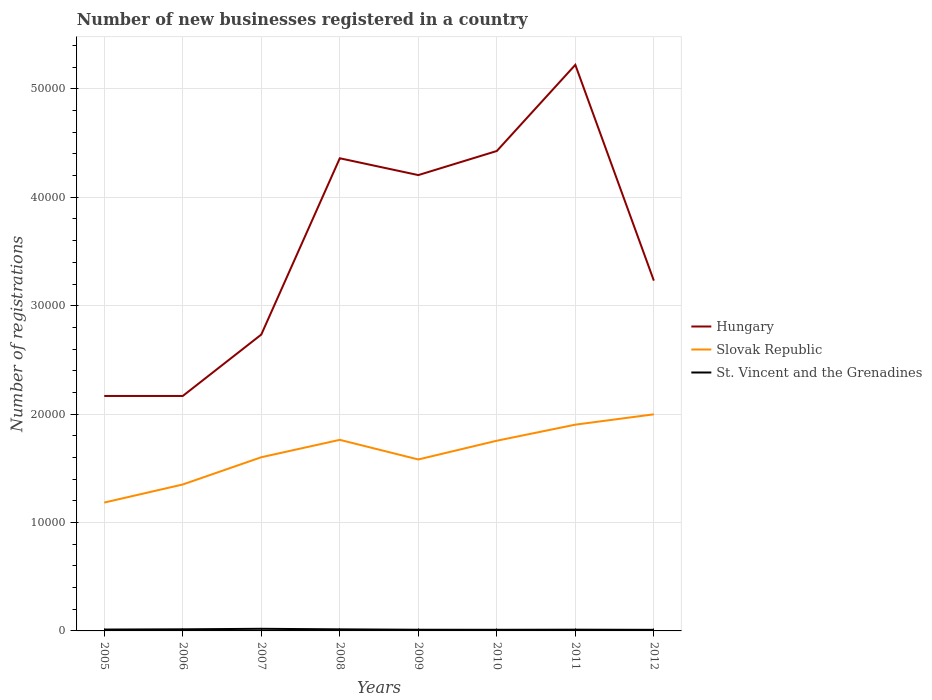How many different coloured lines are there?
Keep it short and to the point. 3. Across all years, what is the maximum number of new businesses registered in Slovak Republic?
Make the answer very short. 1.18e+04. In which year was the number of new businesses registered in Slovak Republic maximum?
Provide a short and direct response. 2005. What is the total number of new businesses registered in Slovak Republic in the graph?
Keep it short and to the point. -5519. What is the difference between the highest and the second highest number of new businesses registered in Slovak Republic?
Your response must be concise. 8139. What is the difference between the highest and the lowest number of new businesses registered in Hungary?
Your response must be concise. 4. How many years are there in the graph?
Give a very brief answer. 8. How many legend labels are there?
Make the answer very short. 3. What is the title of the graph?
Your answer should be very brief. Number of new businesses registered in a country. What is the label or title of the Y-axis?
Keep it short and to the point. Number of registrations. What is the Number of registrations in Hungary in 2005?
Your answer should be compact. 2.17e+04. What is the Number of registrations in Slovak Republic in 2005?
Offer a very short reply. 1.18e+04. What is the Number of registrations in St. Vincent and the Grenadines in 2005?
Keep it short and to the point. 127. What is the Number of registrations of Hungary in 2006?
Offer a very short reply. 2.17e+04. What is the Number of registrations of Slovak Republic in 2006?
Keep it short and to the point. 1.35e+04. What is the Number of registrations of St. Vincent and the Grenadines in 2006?
Provide a succinct answer. 149. What is the Number of registrations in Hungary in 2007?
Your answer should be compact. 2.73e+04. What is the Number of registrations of Slovak Republic in 2007?
Offer a terse response. 1.60e+04. What is the Number of registrations of St. Vincent and the Grenadines in 2007?
Your answer should be very brief. 196. What is the Number of registrations in Hungary in 2008?
Provide a succinct answer. 4.36e+04. What is the Number of registrations in Slovak Republic in 2008?
Provide a short and direct response. 1.76e+04. What is the Number of registrations in St. Vincent and the Grenadines in 2008?
Keep it short and to the point. 145. What is the Number of registrations of Hungary in 2009?
Offer a terse response. 4.20e+04. What is the Number of registrations of Slovak Republic in 2009?
Provide a succinct answer. 1.58e+04. What is the Number of registrations of St. Vincent and the Grenadines in 2009?
Your response must be concise. 109. What is the Number of registrations in Hungary in 2010?
Ensure brevity in your answer.  4.43e+04. What is the Number of registrations in Slovak Republic in 2010?
Keep it short and to the point. 1.75e+04. What is the Number of registrations of St. Vincent and the Grenadines in 2010?
Provide a short and direct response. 105. What is the Number of registrations of Hungary in 2011?
Ensure brevity in your answer.  5.22e+04. What is the Number of registrations in Slovak Republic in 2011?
Give a very brief answer. 1.90e+04. What is the Number of registrations in St. Vincent and the Grenadines in 2011?
Ensure brevity in your answer.  115. What is the Number of registrations of Hungary in 2012?
Your answer should be very brief. 3.23e+04. What is the Number of registrations in Slovak Republic in 2012?
Your answer should be very brief. 2.00e+04. What is the Number of registrations in St. Vincent and the Grenadines in 2012?
Provide a succinct answer. 101. Across all years, what is the maximum Number of registrations in Hungary?
Offer a terse response. 5.22e+04. Across all years, what is the maximum Number of registrations in Slovak Republic?
Make the answer very short. 2.00e+04. Across all years, what is the maximum Number of registrations of St. Vincent and the Grenadines?
Ensure brevity in your answer.  196. Across all years, what is the minimum Number of registrations of Hungary?
Give a very brief answer. 2.17e+04. Across all years, what is the minimum Number of registrations of Slovak Republic?
Your answer should be compact. 1.18e+04. Across all years, what is the minimum Number of registrations of St. Vincent and the Grenadines?
Provide a short and direct response. 101. What is the total Number of registrations of Hungary in the graph?
Make the answer very short. 2.85e+05. What is the total Number of registrations in Slovak Republic in the graph?
Make the answer very short. 1.31e+05. What is the total Number of registrations in St. Vincent and the Grenadines in the graph?
Give a very brief answer. 1047. What is the difference between the Number of registrations in Hungary in 2005 and that in 2006?
Make the answer very short. 0. What is the difference between the Number of registrations of Slovak Republic in 2005 and that in 2006?
Ensure brevity in your answer.  -1667. What is the difference between the Number of registrations in St. Vincent and the Grenadines in 2005 and that in 2006?
Your answer should be compact. -22. What is the difference between the Number of registrations of Hungary in 2005 and that in 2007?
Your answer should be very brief. -5663. What is the difference between the Number of registrations of Slovak Republic in 2005 and that in 2007?
Offer a very short reply. -4180. What is the difference between the Number of registrations in St. Vincent and the Grenadines in 2005 and that in 2007?
Your answer should be very brief. -69. What is the difference between the Number of registrations in Hungary in 2005 and that in 2008?
Offer a terse response. -2.19e+04. What is the difference between the Number of registrations in Slovak Republic in 2005 and that in 2008?
Provide a succinct answer. -5785. What is the difference between the Number of registrations in St. Vincent and the Grenadines in 2005 and that in 2008?
Your answer should be very brief. -18. What is the difference between the Number of registrations of Hungary in 2005 and that in 2009?
Your response must be concise. -2.04e+04. What is the difference between the Number of registrations of Slovak Republic in 2005 and that in 2009?
Offer a very short reply. -3975. What is the difference between the Number of registrations in St. Vincent and the Grenadines in 2005 and that in 2009?
Your answer should be very brief. 18. What is the difference between the Number of registrations in Hungary in 2005 and that in 2010?
Provide a succinct answer. -2.26e+04. What is the difference between the Number of registrations in Slovak Republic in 2005 and that in 2010?
Your response must be concise. -5704. What is the difference between the Number of registrations of St. Vincent and the Grenadines in 2005 and that in 2010?
Provide a short and direct response. 22. What is the difference between the Number of registrations of Hungary in 2005 and that in 2011?
Keep it short and to the point. -3.05e+04. What is the difference between the Number of registrations in Slovak Republic in 2005 and that in 2011?
Provide a succinct answer. -7186. What is the difference between the Number of registrations in St. Vincent and the Grenadines in 2005 and that in 2011?
Your answer should be very brief. 12. What is the difference between the Number of registrations in Hungary in 2005 and that in 2012?
Keep it short and to the point. -1.06e+04. What is the difference between the Number of registrations of Slovak Republic in 2005 and that in 2012?
Provide a succinct answer. -8139. What is the difference between the Number of registrations of St. Vincent and the Grenadines in 2005 and that in 2012?
Provide a short and direct response. 26. What is the difference between the Number of registrations of Hungary in 2006 and that in 2007?
Keep it short and to the point. -5663. What is the difference between the Number of registrations of Slovak Republic in 2006 and that in 2007?
Offer a very short reply. -2513. What is the difference between the Number of registrations in St. Vincent and the Grenadines in 2006 and that in 2007?
Offer a terse response. -47. What is the difference between the Number of registrations in Hungary in 2006 and that in 2008?
Provide a succinct answer. -2.19e+04. What is the difference between the Number of registrations in Slovak Republic in 2006 and that in 2008?
Your answer should be compact. -4118. What is the difference between the Number of registrations in Hungary in 2006 and that in 2009?
Provide a succinct answer. -2.04e+04. What is the difference between the Number of registrations of Slovak Republic in 2006 and that in 2009?
Your response must be concise. -2308. What is the difference between the Number of registrations in Hungary in 2006 and that in 2010?
Offer a very short reply. -2.26e+04. What is the difference between the Number of registrations in Slovak Republic in 2006 and that in 2010?
Keep it short and to the point. -4037. What is the difference between the Number of registrations of St. Vincent and the Grenadines in 2006 and that in 2010?
Make the answer very short. 44. What is the difference between the Number of registrations of Hungary in 2006 and that in 2011?
Provide a succinct answer. -3.05e+04. What is the difference between the Number of registrations of Slovak Republic in 2006 and that in 2011?
Offer a terse response. -5519. What is the difference between the Number of registrations in Hungary in 2006 and that in 2012?
Provide a short and direct response. -1.06e+04. What is the difference between the Number of registrations of Slovak Republic in 2006 and that in 2012?
Make the answer very short. -6472. What is the difference between the Number of registrations in St. Vincent and the Grenadines in 2006 and that in 2012?
Your response must be concise. 48. What is the difference between the Number of registrations in Hungary in 2007 and that in 2008?
Your answer should be compact. -1.63e+04. What is the difference between the Number of registrations of Slovak Republic in 2007 and that in 2008?
Your answer should be compact. -1605. What is the difference between the Number of registrations of Hungary in 2007 and that in 2009?
Your response must be concise. -1.47e+04. What is the difference between the Number of registrations of Slovak Republic in 2007 and that in 2009?
Make the answer very short. 205. What is the difference between the Number of registrations of Hungary in 2007 and that in 2010?
Provide a short and direct response. -1.69e+04. What is the difference between the Number of registrations in Slovak Republic in 2007 and that in 2010?
Provide a short and direct response. -1524. What is the difference between the Number of registrations in St. Vincent and the Grenadines in 2007 and that in 2010?
Provide a short and direct response. 91. What is the difference between the Number of registrations in Hungary in 2007 and that in 2011?
Ensure brevity in your answer.  -2.49e+04. What is the difference between the Number of registrations of Slovak Republic in 2007 and that in 2011?
Give a very brief answer. -3006. What is the difference between the Number of registrations of St. Vincent and the Grenadines in 2007 and that in 2011?
Make the answer very short. 81. What is the difference between the Number of registrations of Hungary in 2007 and that in 2012?
Provide a short and direct response. -4976. What is the difference between the Number of registrations of Slovak Republic in 2007 and that in 2012?
Ensure brevity in your answer.  -3959. What is the difference between the Number of registrations of St. Vincent and the Grenadines in 2007 and that in 2012?
Give a very brief answer. 95. What is the difference between the Number of registrations in Hungary in 2008 and that in 2009?
Offer a terse response. 1552. What is the difference between the Number of registrations of Slovak Republic in 2008 and that in 2009?
Provide a short and direct response. 1810. What is the difference between the Number of registrations of Hungary in 2008 and that in 2010?
Give a very brief answer. -671. What is the difference between the Number of registrations of Hungary in 2008 and that in 2011?
Keep it short and to the point. -8619. What is the difference between the Number of registrations of Slovak Republic in 2008 and that in 2011?
Offer a very short reply. -1401. What is the difference between the Number of registrations of St. Vincent and the Grenadines in 2008 and that in 2011?
Ensure brevity in your answer.  30. What is the difference between the Number of registrations of Hungary in 2008 and that in 2012?
Offer a terse response. 1.13e+04. What is the difference between the Number of registrations of Slovak Republic in 2008 and that in 2012?
Provide a short and direct response. -2354. What is the difference between the Number of registrations in St. Vincent and the Grenadines in 2008 and that in 2012?
Your answer should be very brief. 44. What is the difference between the Number of registrations of Hungary in 2009 and that in 2010?
Offer a terse response. -2223. What is the difference between the Number of registrations of Slovak Republic in 2009 and that in 2010?
Ensure brevity in your answer.  -1729. What is the difference between the Number of registrations of St. Vincent and the Grenadines in 2009 and that in 2010?
Provide a short and direct response. 4. What is the difference between the Number of registrations of Hungary in 2009 and that in 2011?
Give a very brief answer. -1.02e+04. What is the difference between the Number of registrations of Slovak Republic in 2009 and that in 2011?
Keep it short and to the point. -3211. What is the difference between the Number of registrations of St. Vincent and the Grenadines in 2009 and that in 2011?
Your answer should be very brief. -6. What is the difference between the Number of registrations in Hungary in 2009 and that in 2012?
Your response must be concise. 9735. What is the difference between the Number of registrations in Slovak Republic in 2009 and that in 2012?
Offer a very short reply. -4164. What is the difference between the Number of registrations in Hungary in 2010 and that in 2011?
Offer a terse response. -7948. What is the difference between the Number of registrations in Slovak Republic in 2010 and that in 2011?
Offer a terse response. -1482. What is the difference between the Number of registrations of St. Vincent and the Grenadines in 2010 and that in 2011?
Your answer should be very brief. -10. What is the difference between the Number of registrations of Hungary in 2010 and that in 2012?
Keep it short and to the point. 1.20e+04. What is the difference between the Number of registrations of Slovak Republic in 2010 and that in 2012?
Keep it short and to the point. -2435. What is the difference between the Number of registrations in St. Vincent and the Grenadines in 2010 and that in 2012?
Provide a succinct answer. 4. What is the difference between the Number of registrations of Hungary in 2011 and that in 2012?
Provide a short and direct response. 1.99e+04. What is the difference between the Number of registrations in Slovak Republic in 2011 and that in 2012?
Provide a short and direct response. -953. What is the difference between the Number of registrations of Hungary in 2005 and the Number of registrations of Slovak Republic in 2006?
Ensure brevity in your answer.  8165. What is the difference between the Number of registrations in Hungary in 2005 and the Number of registrations in St. Vincent and the Grenadines in 2006?
Offer a very short reply. 2.15e+04. What is the difference between the Number of registrations of Slovak Republic in 2005 and the Number of registrations of St. Vincent and the Grenadines in 2006?
Your answer should be very brief. 1.17e+04. What is the difference between the Number of registrations of Hungary in 2005 and the Number of registrations of Slovak Republic in 2007?
Your answer should be very brief. 5652. What is the difference between the Number of registrations in Hungary in 2005 and the Number of registrations in St. Vincent and the Grenadines in 2007?
Your answer should be compact. 2.15e+04. What is the difference between the Number of registrations of Slovak Republic in 2005 and the Number of registrations of St. Vincent and the Grenadines in 2007?
Provide a succinct answer. 1.16e+04. What is the difference between the Number of registrations in Hungary in 2005 and the Number of registrations in Slovak Republic in 2008?
Offer a terse response. 4047. What is the difference between the Number of registrations in Hungary in 2005 and the Number of registrations in St. Vincent and the Grenadines in 2008?
Keep it short and to the point. 2.15e+04. What is the difference between the Number of registrations in Slovak Republic in 2005 and the Number of registrations in St. Vincent and the Grenadines in 2008?
Offer a very short reply. 1.17e+04. What is the difference between the Number of registrations in Hungary in 2005 and the Number of registrations in Slovak Republic in 2009?
Make the answer very short. 5857. What is the difference between the Number of registrations in Hungary in 2005 and the Number of registrations in St. Vincent and the Grenadines in 2009?
Your answer should be compact. 2.16e+04. What is the difference between the Number of registrations in Slovak Republic in 2005 and the Number of registrations in St. Vincent and the Grenadines in 2009?
Provide a short and direct response. 1.17e+04. What is the difference between the Number of registrations of Hungary in 2005 and the Number of registrations of Slovak Republic in 2010?
Your answer should be compact. 4128. What is the difference between the Number of registrations in Hungary in 2005 and the Number of registrations in St. Vincent and the Grenadines in 2010?
Your answer should be very brief. 2.16e+04. What is the difference between the Number of registrations of Slovak Republic in 2005 and the Number of registrations of St. Vincent and the Grenadines in 2010?
Ensure brevity in your answer.  1.17e+04. What is the difference between the Number of registrations of Hungary in 2005 and the Number of registrations of Slovak Republic in 2011?
Offer a very short reply. 2646. What is the difference between the Number of registrations of Hungary in 2005 and the Number of registrations of St. Vincent and the Grenadines in 2011?
Give a very brief answer. 2.16e+04. What is the difference between the Number of registrations of Slovak Republic in 2005 and the Number of registrations of St. Vincent and the Grenadines in 2011?
Provide a succinct answer. 1.17e+04. What is the difference between the Number of registrations in Hungary in 2005 and the Number of registrations in Slovak Republic in 2012?
Provide a short and direct response. 1693. What is the difference between the Number of registrations of Hungary in 2005 and the Number of registrations of St. Vincent and the Grenadines in 2012?
Give a very brief answer. 2.16e+04. What is the difference between the Number of registrations in Slovak Republic in 2005 and the Number of registrations in St. Vincent and the Grenadines in 2012?
Your answer should be very brief. 1.17e+04. What is the difference between the Number of registrations of Hungary in 2006 and the Number of registrations of Slovak Republic in 2007?
Keep it short and to the point. 5652. What is the difference between the Number of registrations of Hungary in 2006 and the Number of registrations of St. Vincent and the Grenadines in 2007?
Offer a very short reply. 2.15e+04. What is the difference between the Number of registrations in Slovak Republic in 2006 and the Number of registrations in St. Vincent and the Grenadines in 2007?
Your answer should be very brief. 1.33e+04. What is the difference between the Number of registrations in Hungary in 2006 and the Number of registrations in Slovak Republic in 2008?
Offer a terse response. 4047. What is the difference between the Number of registrations of Hungary in 2006 and the Number of registrations of St. Vincent and the Grenadines in 2008?
Make the answer very short. 2.15e+04. What is the difference between the Number of registrations in Slovak Republic in 2006 and the Number of registrations in St. Vincent and the Grenadines in 2008?
Ensure brevity in your answer.  1.34e+04. What is the difference between the Number of registrations of Hungary in 2006 and the Number of registrations of Slovak Republic in 2009?
Your response must be concise. 5857. What is the difference between the Number of registrations of Hungary in 2006 and the Number of registrations of St. Vincent and the Grenadines in 2009?
Your answer should be very brief. 2.16e+04. What is the difference between the Number of registrations of Slovak Republic in 2006 and the Number of registrations of St. Vincent and the Grenadines in 2009?
Your answer should be compact. 1.34e+04. What is the difference between the Number of registrations in Hungary in 2006 and the Number of registrations in Slovak Republic in 2010?
Your answer should be very brief. 4128. What is the difference between the Number of registrations in Hungary in 2006 and the Number of registrations in St. Vincent and the Grenadines in 2010?
Offer a very short reply. 2.16e+04. What is the difference between the Number of registrations of Slovak Republic in 2006 and the Number of registrations of St. Vincent and the Grenadines in 2010?
Offer a very short reply. 1.34e+04. What is the difference between the Number of registrations in Hungary in 2006 and the Number of registrations in Slovak Republic in 2011?
Provide a succinct answer. 2646. What is the difference between the Number of registrations of Hungary in 2006 and the Number of registrations of St. Vincent and the Grenadines in 2011?
Provide a short and direct response. 2.16e+04. What is the difference between the Number of registrations in Slovak Republic in 2006 and the Number of registrations in St. Vincent and the Grenadines in 2011?
Your answer should be compact. 1.34e+04. What is the difference between the Number of registrations of Hungary in 2006 and the Number of registrations of Slovak Republic in 2012?
Your response must be concise. 1693. What is the difference between the Number of registrations in Hungary in 2006 and the Number of registrations in St. Vincent and the Grenadines in 2012?
Offer a terse response. 2.16e+04. What is the difference between the Number of registrations of Slovak Republic in 2006 and the Number of registrations of St. Vincent and the Grenadines in 2012?
Offer a very short reply. 1.34e+04. What is the difference between the Number of registrations of Hungary in 2007 and the Number of registrations of Slovak Republic in 2008?
Ensure brevity in your answer.  9710. What is the difference between the Number of registrations in Hungary in 2007 and the Number of registrations in St. Vincent and the Grenadines in 2008?
Your response must be concise. 2.72e+04. What is the difference between the Number of registrations in Slovak Republic in 2007 and the Number of registrations in St. Vincent and the Grenadines in 2008?
Your response must be concise. 1.59e+04. What is the difference between the Number of registrations of Hungary in 2007 and the Number of registrations of Slovak Republic in 2009?
Your response must be concise. 1.15e+04. What is the difference between the Number of registrations in Hungary in 2007 and the Number of registrations in St. Vincent and the Grenadines in 2009?
Your answer should be very brief. 2.72e+04. What is the difference between the Number of registrations of Slovak Republic in 2007 and the Number of registrations of St. Vincent and the Grenadines in 2009?
Offer a terse response. 1.59e+04. What is the difference between the Number of registrations of Hungary in 2007 and the Number of registrations of Slovak Republic in 2010?
Give a very brief answer. 9791. What is the difference between the Number of registrations of Hungary in 2007 and the Number of registrations of St. Vincent and the Grenadines in 2010?
Give a very brief answer. 2.72e+04. What is the difference between the Number of registrations in Slovak Republic in 2007 and the Number of registrations in St. Vincent and the Grenadines in 2010?
Your response must be concise. 1.59e+04. What is the difference between the Number of registrations in Hungary in 2007 and the Number of registrations in Slovak Republic in 2011?
Provide a short and direct response. 8309. What is the difference between the Number of registrations of Hungary in 2007 and the Number of registrations of St. Vincent and the Grenadines in 2011?
Keep it short and to the point. 2.72e+04. What is the difference between the Number of registrations in Slovak Republic in 2007 and the Number of registrations in St. Vincent and the Grenadines in 2011?
Your answer should be very brief. 1.59e+04. What is the difference between the Number of registrations in Hungary in 2007 and the Number of registrations in Slovak Republic in 2012?
Provide a short and direct response. 7356. What is the difference between the Number of registrations in Hungary in 2007 and the Number of registrations in St. Vincent and the Grenadines in 2012?
Offer a very short reply. 2.72e+04. What is the difference between the Number of registrations in Slovak Republic in 2007 and the Number of registrations in St. Vincent and the Grenadines in 2012?
Offer a very short reply. 1.59e+04. What is the difference between the Number of registrations of Hungary in 2008 and the Number of registrations of Slovak Republic in 2009?
Your response must be concise. 2.78e+04. What is the difference between the Number of registrations in Hungary in 2008 and the Number of registrations in St. Vincent and the Grenadines in 2009?
Your answer should be very brief. 4.35e+04. What is the difference between the Number of registrations in Slovak Republic in 2008 and the Number of registrations in St. Vincent and the Grenadines in 2009?
Your answer should be very brief. 1.75e+04. What is the difference between the Number of registrations of Hungary in 2008 and the Number of registrations of Slovak Republic in 2010?
Make the answer very short. 2.61e+04. What is the difference between the Number of registrations in Hungary in 2008 and the Number of registrations in St. Vincent and the Grenadines in 2010?
Ensure brevity in your answer.  4.35e+04. What is the difference between the Number of registrations in Slovak Republic in 2008 and the Number of registrations in St. Vincent and the Grenadines in 2010?
Make the answer very short. 1.75e+04. What is the difference between the Number of registrations of Hungary in 2008 and the Number of registrations of Slovak Republic in 2011?
Your answer should be compact. 2.46e+04. What is the difference between the Number of registrations of Hungary in 2008 and the Number of registrations of St. Vincent and the Grenadines in 2011?
Offer a terse response. 4.35e+04. What is the difference between the Number of registrations in Slovak Republic in 2008 and the Number of registrations in St. Vincent and the Grenadines in 2011?
Provide a succinct answer. 1.75e+04. What is the difference between the Number of registrations of Hungary in 2008 and the Number of registrations of Slovak Republic in 2012?
Provide a short and direct response. 2.36e+04. What is the difference between the Number of registrations of Hungary in 2008 and the Number of registrations of St. Vincent and the Grenadines in 2012?
Ensure brevity in your answer.  4.35e+04. What is the difference between the Number of registrations in Slovak Republic in 2008 and the Number of registrations in St. Vincent and the Grenadines in 2012?
Provide a short and direct response. 1.75e+04. What is the difference between the Number of registrations of Hungary in 2009 and the Number of registrations of Slovak Republic in 2010?
Provide a succinct answer. 2.45e+04. What is the difference between the Number of registrations in Hungary in 2009 and the Number of registrations in St. Vincent and the Grenadines in 2010?
Your answer should be compact. 4.19e+04. What is the difference between the Number of registrations in Slovak Republic in 2009 and the Number of registrations in St. Vincent and the Grenadines in 2010?
Your response must be concise. 1.57e+04. What is the difference between the Number of registrations of Hungary in 2009 and the Number of registrations of Slovak Republic in 2011?
Provide a short and direct response. 2.30e+04. What is the difference between the Number of registrations of Hungary in 2009 and the Number of registrations of St. Vincent and the Grenadines in 2011?
Offer a terse response. 4.19e+04. What is the difference between the Number of registrations in Slovak Republic in 2009 and the Number of registrations in St. Vincent and the Grenadines in 2011?
Give a very brief answer. 1.57e+04. What is the difference between the Number of registrations in Hungary in 2009 and the Number of registrations in Slovak Republic in 2012?
Give a very brief answer. 2.21e+04. What is the difference between the Number of registrations of Hungary in 2009 and the Number of registrations of St. Vincent and the Grenadines in 2012?
Your answer should be compact. 4.19e+04. What is the difference between the Number of registrations in Slovak Republic in 2009 and the Number of registrations in St. Vincent and the Grenadines in 2012?
Make the answer very short. 1.57e+04. What is the difference between the Number of registrations of Hungary in 2010 and the Number of registrations of Slovak Republic in 2011?
Offer a very short reply. 2.52e+04. What is the difference between the Number of registrations in Hungary in 2010 and the Number of registrations in St. Vincent and the Grenadines in 2011?
Your answer should be compact. 4.42e+04. What is the difference between the Number of registrations in Slovak Republic in 2010 and the Number of registrations in St. Vincent and the Grenadines in 2011?
Provide a short and direct response. 1.74e+04. What is the difference between the Number of registrations in Hungary in 2010 and the Number of registrations in Slovak Republic in 2012?
Offer a very short reply. 2.43e+04. What is the difference between the Number of registrations in Hungary in 2010 and the Number of registrations in St. Vincent and the Grenadines in 2012?
Keep it short and to the point. 4.42e+04. What is the difference between the Number of registrations of Slovak Republic in 2010 and the Number of registrations of St. Vincent and the Grenadines in 2012?
Keep it short and to the point. 1.74e+04. What is the difference between the Number of registrations of Hungary in 2011 and the Number of registrations of Slovak Republic in 2012?
Your answer should be compact. 3.22e+04. What is the difference between the Number of registrations of Hungary in 2011 and the Number of registrations of St. Vincent and the Grenadines in 2012?
Provide a short and direct response. 5.21e+04. What is the difference between the Number of registrations in Slovak Republic in 2011 and the Number of registrations in St. Vincent and the Grenadines in 2012?
Your answer should be compact. 1.89e+04. What is the average Number of registrations in Hungary per year?
Your answer should be very brief. 3.56e+04. What is the average Number of registrations of Slovak Republic per year?
Offer a very short reply. 1.64e+04. What is the average Number of registrations of St. Vincent and the Grenadines per year?
Offer a very short reply. 130.88. In the year 2005, what is the difference between the Number of registrations in Hungary and Number of registrations in Slovak Republic?
Provide a short and direct response. 9832. In the year 2005, what is the difference between the Number of registrations of Hungary and Number of registrations of St. Vincent and the Grenadines?
Provide a succinct answer. 2.15e+04. In the year 2005, what is the difference between the Number of registrations of Slovak Republic and Number of registrations of St. Vincent and the Grenadines?
Offer a very short reply. 1.17e+04. In the year 2006, what is the difference between the Number of registrations of Hungary and Number of registrations of Slovak Republic?
Offer a very short reply. 8165. In the year 2006, what is the difference between the Number of registrations in Hungary and Number of registrations in St. Vincent and the Grenadines?
Offer a very short reply. 2.15e+04. In the year 2006, what is the difference between the Number of registrations of Slovak Republic and Number of registrations of St. Vincent and the Grenadines?
Give a very brief answer. 1.34e+04. In the year 2007, what is the difference between the Number of registrations in Hungary and Number of registrations in Slovak Republic?
Make the answer very short. 1.13e+04. In the year 2007, what is the difference between the Number of registrations in Hungary and Number of registrations in St. Vincent and the Grenadines?
Provide a succinct answer. 2.71e+04. In the year 2007, what is the difference between the Number of registrations of Slovak Republic and Number of registrations of St. Vincent and the Grenadines?
Provide a succinct answer. 1.58e+04. In the year 2008, what is the difference between the Number of registrations in Hungary and Number of registrations in Slovak Republic?
Give a very brief answer. 2.60e+04. In the year 2008, what is the difference between the Number of registrations of Hungary and Number of registrations of St. Vincent and the Grenadines?
Ensure brevity in your answer.  4.35e+04. In the year 2008, what is the difference between the Number of registrations in Slovak Republic and Number of registrations in St. Vincent and the Grenadines?
Provide a succinct answer. 1.75e+04. In the year 2009, what is the difference between the Number of registrations of Hungary and Number of registrations of Slovak Republic?
Provide a short and direct response. 2.62e+04. In the year 2009, what is the difference between the Number of registrations of Hungary and Number of registrations of St. Vincent and the Grenadines?
Keep it short and to the point. 4.19e+04. In the year 2009, what is the difference between the Number of registrations in Slovak Republic and Number of registrations in St. Vincent and the Grenadines?
Provide a succinct answer. 1.57e+04. In the year 2010, what is the difference between the Number of registrations of Hungary and Number of registrations of Slovak Republic?
Offer a very short reply. 2.67e+04. In the year 2010, what is the difference between the Number of registrations of Hungary and Number of registrations of St. Vincent and the Grenadines?
Ensure brevity in your answer.  4.42e+04. In the year 2010, what is the difference between the Number of registrations of Slovak Republic and Number of registrations of St. Vincent and the Grenadines?
Offer a very short reply. 1.74e+04. In the year 2011, what is the difference between the Number of registrations of Hungary and Number of registrations of Slovak Republic?
Offer a very short reply. 3.32e+04. In the year 2011, what is the difference between the Number of registrations in Hungary and Number of registrations in St. Vincent and the Grenadines?
Keep it short and to the point. 5.21e+04. In the year 2011, what is the difference between the Number of registrations in Slovak Republic and Number of registrations in St. Vincent and the Grenadines?
Give a very brief answer. 1.89e+04. In the year 2012, what is the difference between the Number of registrations of Hungary and Number of registrations of Slovak Republic?
Give a very brief answer. 1.23e+04. In the year 2012, what is the difference between the Number of registrations of Hungary and Number of registrations of St. Vincent and the Grenadines?
Provide a short and direct response. 3.22e+04. In the year 2012, what is the difference between the Number of registrations in Slovak Republic and Number of registrations in St. Vincent and the Grenadines?
Provide a succinct answer. 1.99e+04. What is the ratio of the Number of registrations of Hungary in 2005 to that in 2006?
Make the answer very short. 1. What is the ratio of the Number of registrations of Slovak Republic in 2005 to that in 2006?
Keep it short and to the point. 0.88. What is the ratio of the Number of registrations of St. Vincent and the Grenadines in 2005 to that in 2006?
Ensure brevity in your answer.  0.85. What is the ratio of the Number of registrations of Hungary in 2005 to that in 2007?
Your response must be concise. 0.79. What is the ratio of the Number of registrations in Slovak Republic in 2005 to that in 2007?
Keep it short and to the point. 0.74. What is the ratio of the Number of registrations in St. Vincent and the Grenadines in 2005 to that in 2007?
Provide a short and direct response. 0.65. What is the ratio of the Number of registrations in Hungary in 2005 to that in 2008?
Ensure brevity in your answer.  0.5. What is the ratio of the Number of registrations in Slovak Republic in 2005 to that in 2008?
Your answer should be very brief. 0.67. What is the ratio of the Number of registrations of St. Vincent and the Grenadines in 2005 to that in 2008?
Offer a terse response. 0.88. What is the ratio of the Number of registrations of Hungary in 2005 to that in 2009?
Provide a succinct answer. 0.52. What is the ratio of the Number of registrations in Slovak Republic in 2005 to that in 2009?
Give a very brief answer. 0.75. What is the ratio of the Number of registrations in St. Vincent and the Grenadines in 2005 to that in 2009?
Offer a very short reply. 1.17. What is the ratio of the Number of registrations of Hungary in 2005 to that in 2010?
Keep it short and to the point. 0.49. What is the ratio of the Number of registrations of Slovak Republic in 2005 to that in 2010?
Your answer should be very brief. 0.67. What is the ratio of the Number of registrations in St. Vincent and the Grenadines in 2005 to that in 2010?
Your response must be concise. 1.21. What is the ratio of the Number of registrations in Hungary in 2005 to that in 2011?
Make the answer very short. 0.41. What is the ratio of the Number of registrations in Slovak Republic in 2005 to that in 2011?
Provide a short and direct response. 0.62. What is the ratio of the Number of registrations of St. Vincent and the Grenadines in 2005 to that in 2011?
Give a very brief answer. 1.1. What is the ratio of the Number of registrations of Hungary in 2005 to that in 2012?
Provide a succinct answer. 0.67. What is the ratio of the Number of registrations of Slovak Republic in 2005 to that in 2012?
Your response must be concise. 0.59. What is the ratio of the Number of registrations of St. Vincent and the Grenadines in 2005 to that in 2012?
Offer a terse response. 1.26. What is the ratio of the Number of registrations of Hungary in 2006 to that in 2007?
Ensure brevity in your answer.  0.79. What is the ratio of the Number of registrations in Slovak Republic in 2006 to that in 2007?
Offer a terse response. 0.84. What is the ratio of the Number of registrations in St. Vincent and the Grenadines in 2006 to that in 2007?
Make the answer very short. 0.76. What is the ratio of the Number of registrations of Hungary in 2006 to that in 2008?
Offer a very short reply. 0.5. What is the ratio of the Number of registrations of Slovak Republic in 2006 to that in 2008?
Provide a succinct answer. 0.77. What is the ratio of the Number of registrations in St. Vincent and the Grenadines in 2006 to that in 2008?
Your response must be concise. 1.03. What is the ratio of the Number of registrations in Hungary in 2006 to that in 2009?
Your answer should be compact. 0.52. What is the ratio of the Number of registrations in Slovak Republic in 2006 to that in 2009?
Make the answer very short. 0.85. What is the ratio of the Number of registrations of St. Vincent and the Grenadines in 2006 to that in 2009?
Provide a short and direct response. 1.37. What is the ratio of the Number of registrations in Hungary in 2006 to that in 2010?
Your answer should be compact. 0.49. What is the ratio of the Number of registrations of Slovak Republic in 2006 to that in 2010?
Provide a succinct answer. 0.77. What is the ratio of the Number of registrations of St. Vincent and the Grenadines in 2006 to that in 2010?
Offer a very short reply. 1.42. What is the ratio of the Number of registrations of Hungary in 2006 to that in 2011?
Your answer should be very brief. 0.41. What is the ratio of the Number of registrations in Slovak Republic in 2006 to that in 2011?
Offer a terse response. 0.71. What is the ratio of the Number of registrations of St. Vincent and the Grenadines in 2006 to that in 2011?
Offer a very short reply. 1.3. What is the ratio of the Number of registrations in Hungary in 2006 to that in 2012?
Your answer should be compact. 0.67. What is the ratio of the Number of registrations in Slovak Republic in 2006 to that in 2012?
Provide a short and direct response. 0.68. What is the ratio of the Number of registrations in St. Vincent and the Grenadines in 2006 to that in 2012?
Your answer should be very brief. 1.48. What is the ratio of the Number of registrations in Hungary in 2007 to that in 2008?
Make the answer very short. 0.63. What is the ratio of the Number of registrations in Slovak Republic in 2007 to that in 2008?
Your answer should be very brief. 0.91. What is the ratio of the Number of registrations in St. Vincent and the Grenadines in 2007 to that in 2008?
Give a very brief answer. 1.35. What is the ratio of the Number of registrations of Hungary in 2007 to that in 2009?
Your response must be concise. 0.65. What is the ratio of the Number of registrations of Slovak Republic in 2007 to that in 2009?
Your answer should be compact. 1.01. What is the ratio of the Number of registrations of St. Vincent and the Grenadines in 2007 to that in 2009?
Your answer should be compact. 1.8. What is the ratio of the Number of registrations in Hungary in 2007 to that in 2010?
Your response must be concise. 0.62. What is the ratio of the Number of registrations in Slovak Republic in 2007 to that in 2010?
Offer a terse response. 0.91. What is the ratio of the Number of registrations of St. Vincent and the Grenadines in 2007 to that in 2010?
Make the answer very short. 1.87. What is the ratio of the Number of registrations in Hungary in 2007 to that in 2011?
Offer a very short reply. 0.52. What is the ratio of the Number of registrations of Slovak Republic in 2007 to that in 2011?
Provide a succinct answer. 0.84. What is the ratio of the Number of registrations of St. Vincent and the Grenadines in 2007 to that in 2011?
Give a very brief answer. 1.7. What is the ratio of the Number of registrations in Hungary in 2007 to that in 2012?
Your answer should be compact. 0.85. What is the ratio of the Number of registrations in Slovak Republic in 2007 to that in 2012?
Give a very brief answer. 0.8. What is the ratio of the Number of registrations of St. Vincent and the Grenadines in 2007 to that in 2012?
Provide a short and direct response. 1.94. What is the ratio of the Number of registrations in Hungary in 2008 to that in 2009?
Ensure brevity in your answer.  1.04. What is the ratio of the Number of registrations of Slovak Republic in 2008 to that in 2009?
Provide a short and direct response. 1.11. What is the ratio of the Number of registrations of St. Vincent and the Grenadines in 2008 to that in 2009?
Offer a very short reply. 1.33. What is the ratio of the Number of registrations in Slovak Republic in 2008 to that in 2010?
Offer a terse response. 1. What is the ratio of the Number of registrations in St. Vincent and the Grenadines in 2008 to that in 2010?
Make the answer very short. 1.38. What is the ratio of the Number of registrations of Hungary in 2008 to that in 2011?
Offer a terse response. 0.83. What is the ratio of the Number of registrations in Slovak Republic in 2008 to that in 2011?
Your response must be concise. 0.93. What is the ratio of the Number of registrations in St. Vincent and the Grenadines in 2008 to that in 2011?
Give a very brief answer. 1.26. What is the ratio of the Number of registrations in Hungary in 2008 to that in 2012?
Provide a succinct answer. 1.35. What is the ratio of the Number of registrations of Slovak Republic in 2008 to that in 2012?
Give a very brief answer. 0.88. What is the ratio of the Number of registrations in St. Vincent and the Grenadines in 2008 to that in 2012?
Provide a succinct answer. 1.44. What is the ratio of the Number of registrations in Hungary in 2009 to that in 2010?
Your answer should be very brief. 0.95. What is the ratio of the Number of registrations of Slovak Republic in 2009 to that in 2010?
Provide a succinct answer. 0.9. What is the ratio of the Number of registrations of St. Vincent and the Grenadines in 2009 to that in 2010?
Offer a terse response. 1.04. What is the ratio of the Number of registrations of Hungary in 2009 to that in 2011?
Ensure brevity in your answer.  0.81. What is the ratio of the Number of registrations of Slovak Republic in 2009 to that in 2011?
Provide a succinct answer. 0.83. What is the ratio of the Number of registrations in St. Vincent and the Grenadines in 2009 to that in 2011?
Offer a very short reply. 0.95. What is the ratio of the Number of registrations in Hungary in 2009 to that in 2012?
Your answer should be very brief. 1.3. What is the ratio of the Number of registrations in Slovak Republic in 2009 to that in 2012?
Make the answer very short. 0.79. What is the ratio of the Number of registrations of St. Vincent and the Grenadines in 2009 to that in 2012?
Your answer should be very brief. 1.08. What is the ratio of the Number of registrations in Hungary in 2010 to that in 2011?
Offer a very short reply. 0.85. What is the ratio of the Number of registrations in Slovak Republic in 2010 to that in 2011?
Offer a terse response. 0.92. What is the ratio of the Number of registrations of St. Vincent and the Grenadines in 2010 to that in 2011?
Your answer should be compact. 0.91. What is the ratio of the Number of registrations in Hungary in 2010 to that in 2012?
Ensure brevity in your answer.  1.37. What is the ratio of the Number of registrations in Slovak Republic in 2010 to that in 2012?
Offer a very short reply. 0.88. What is the ratio of the Number of registrations of St. Vincent and the Grenadines in 2010 to that in 2012?
Offer a very short reply. 1.04. What is the ratio of the Number of registrations of Hungary in 2011 to that in 2012?
Provide a short and direct response. 1.62. What is the ratio of the Number of registrations of Slovak Republic in 2011 to that in 2012?
Provide a short and direct response. 0.95. What is the ratio of the Number of registrations in St. Vincent and the Grenadines in 2011 to that in 2012?
Provide a short and direct response. 1.14. What is the difference between the highest and the second highest Number of registrations in Hungary?
Provide a succinct answer. 7948. What is the difference between the highest and the second highest Number of registrations of Slovak Republic?
Your response must be concise. 953. What is the difference between the highest and the second highest Number of registrations in St. Vincent and the Grenadines?
Your answer should be very brief. 47. What is the difference between the highest and the lowest Number of registrations in Hungary?
Ensure brevity in your answer.  3.05e+04. What is the difference between the highest and the lowest Number of registrations in Slovak Republic?
Provide a succinct answer. 8139. 